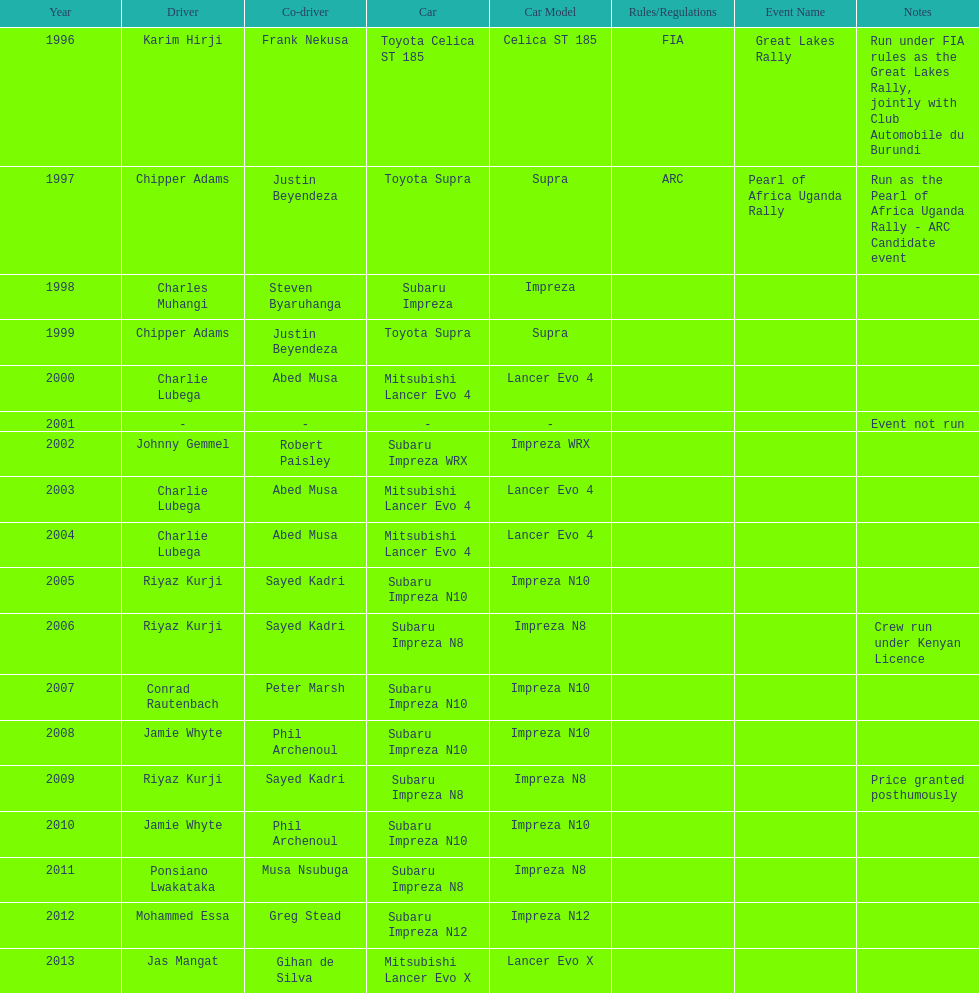Do chipper adams and justin beyendeza have more than 3 wins? No. Write the full table. {'header': ['Year', 'Driver', 'Co-driver', 'Car', 'Car Model', 'Rules/Regulations', 'Event Name', 'Notes'], 'rows': [['1996', 'Karim Hirji', 'Frank Nekusa', 'Toyota Celica ST 185', 'Celica ST 185', 'FIA', 'Great Lakes Rally', 'Run under FIA rules as the Great Lakes Rally, jointly with Club Automobile du Burundi'], ['1997', 'Chipper Adams', 'Justin Beyendeza', 'Toyota Supra', 'Supra', 'ARC', 'Pearl of Africa Uganda Rally', 'Run as the Pearl of Africa Uganda Rally - ARC Candidate event'], ['1998', 'Charles Muhangi', 'Steven Byaruhanga', 'Subaru Impreza', 'Impreza', '', '', ''], ['1999', 'Chipper Adams', 'Justin Beyendeza', 'Toyota Supra', 'Supra', '', '', ''], ['2000', 'Charlie Lubega', 'Abed Musa', 'Mitsubishi Lancer Evo 4', 'Lancer Evo 4', '', '', ''], ['2001', '-', '-', '-', '-', '', '', 'Event not run'], ['2002', 'Johnny Gemmel', 'Robert Paisley', 'Subaru Impreza WRX', 'Impreza WRX', '', '', ''], ['2003', 'Charlie Lubega', 'Abed Musa', 'Mitsubishi Lancer Evo 4', 'Lancer Evo 4', '', '', ''], ['2004', 'Charlie Lubega', 'Abed Musa', 'Mitsubishi Lancer Evo 4', 'Lancer Evo 4', '', '', ''], ['2005', 'Riyaz Kurji', 'Sayed Kadri', 'Subaru Impreza N10', 'Impreza N10', '', '', ''], ['2006', 'Riyaz Kurji', 'Sayed Kadri', 'Subaru Impreza N8', 'Impreza N8', '', '', 'Crew run under Kenyan Licence'], ['2007', 'Conrad Rautenbach', 'Peter Marsh', 'Subaru Impreza N10', 'Impreza N10', '', '', ''], ['2008', 'Jamie Whyte', 'Phil Archenoul', 'Subaru Impreza N10', 'Impreza N10', '', '', ''], ['2009', 'Riyaz Kurji', 'Sayed Kadri', 'Subaru Impreza N8', 'Impreza N8', '', '', 'Price granted posthumously'], ['2010', 'Jamie Whyte', 'Phil Archenoul', 'Subaru Impreza N10', 'Impreza N10', '', '', ''], ['2011', 'Ponsiano Lwakataka', 'Musa Nsubuga', 'Subaru Impreza N8', 'Impreza N8', '', '', ''], ['2012', 'Mohammed Essa', 'Greg Stead', 'Subaru Impreza N12', 'Impreza N12', '', '', ''], ['2013', 'Jas Mangat', 'Gihan de Silva', 'Mitsubishi Lancer Evo X', 'Lancer Evo X', '', '', '']]} 